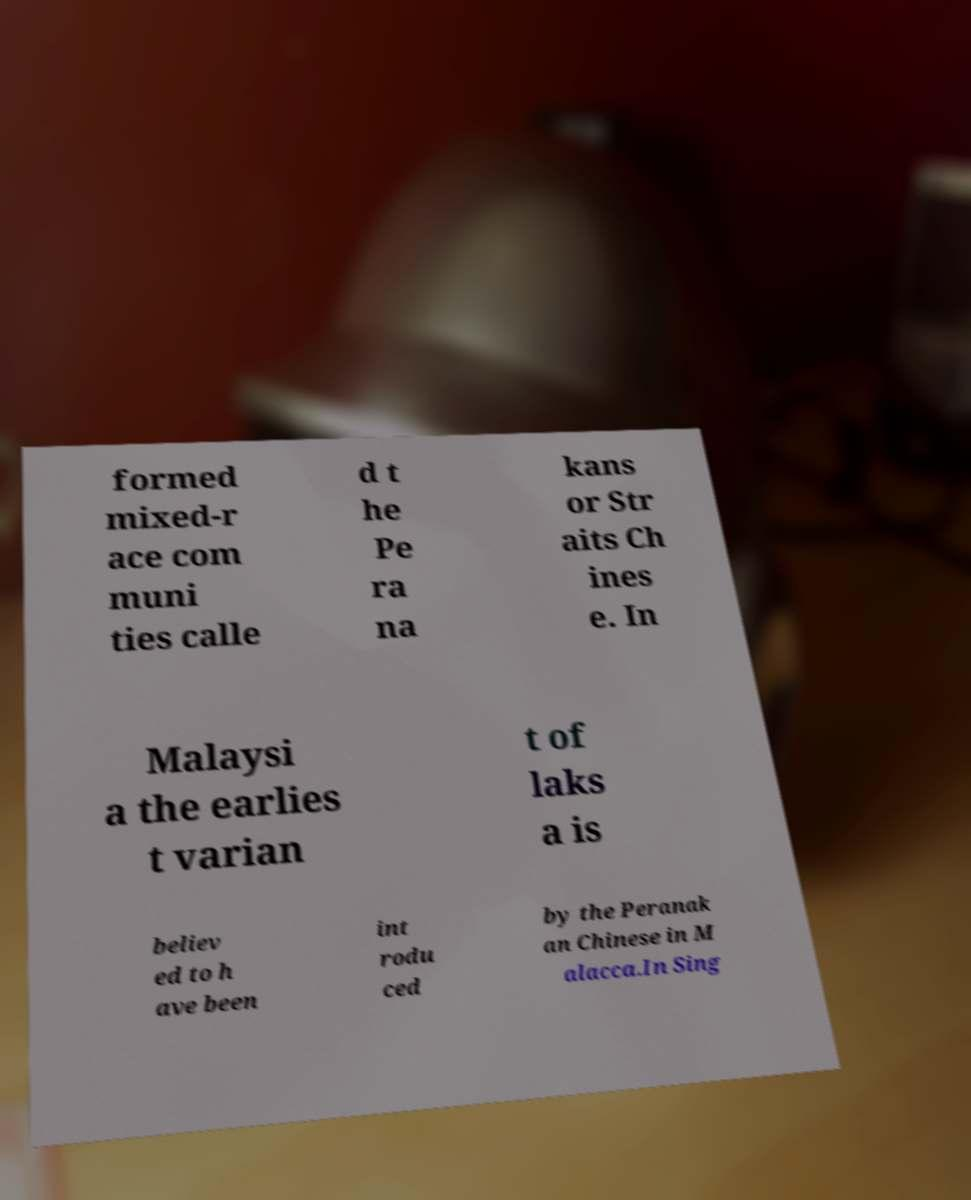Could you assist in decoding the text presented in this image and type it out clearly? formed mixed-r ace com muni ties calle d t he Pe ra na kans or Str aits Ch ines e. In Malaysi a the earlies t varian t of laks a is believ ed to h ave been int rodu ced by the Peranak an Chinese in M alacca.In Sing 